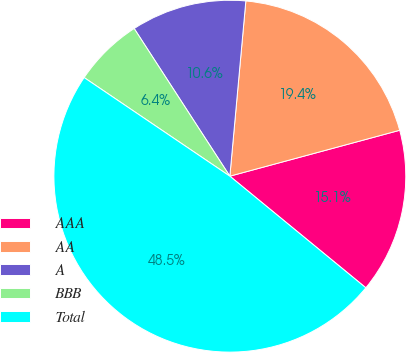Convert chart to OTSL. <chart><loc_0><loc_0><loc_500><loc_500><pie_chart><fcel>AAA<fcel>AA<fcel>A<fcel>BBB<fcel>Total<nl><fcel>15.14%<fcel>19.35%<fcel>10.6%<fcel>6.38%<fcel>48.53%<nl></chart> 